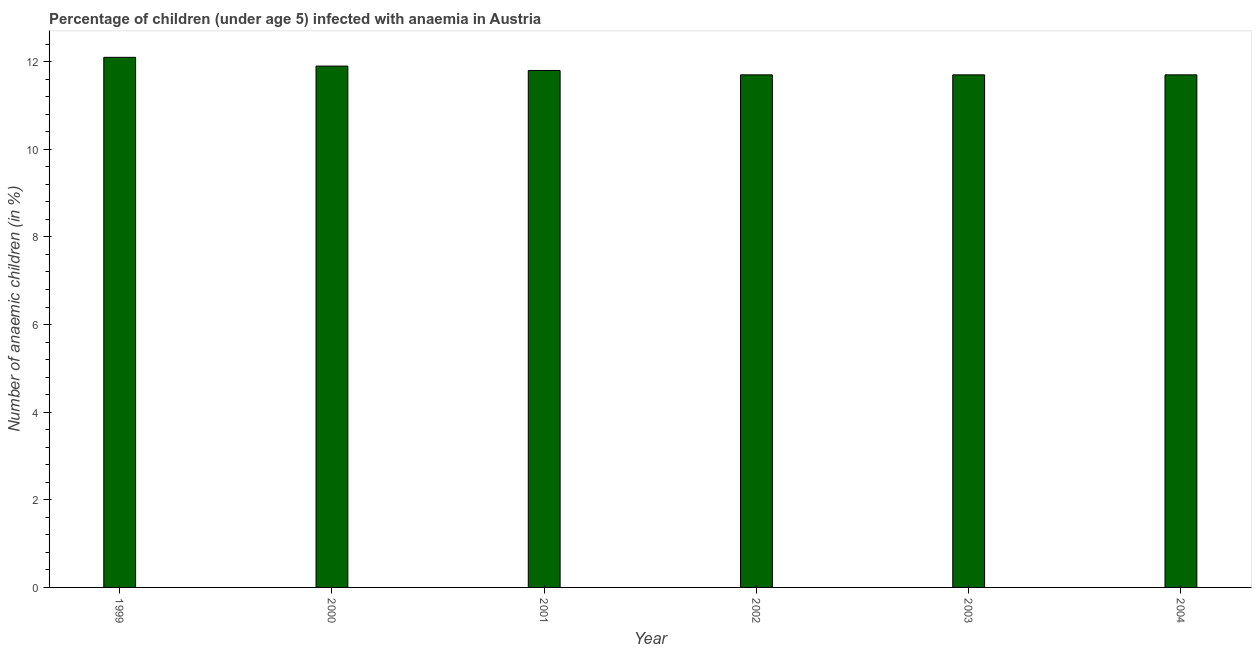What is the title of the graph?
Keep it short and to the point. Percentage of children (under age 5) infected with anaemia in Austria. What is the label or title of the X-axis?
Offer a very short reply. Year. What is the label or title of the Y-axis?
Offer a terse response. Number of anaemic children (in %). What is the number of anaemic children in 2002?
Provide a succinct answer. 11.7. Across all years, what is the maximum number of anaemic children?
Your answer should be compact. 12.1. Across all years, what is the minimum number of anaemic children?
Offer a very short reply. 11.7. In which year was the number of anaemic children minimum?
Your answer should be very brief. 2002. What is the sum of the number of anaemic children?
Provide a short and direct response. 70.9. What is the average number of anaemic children per year?
Provide a succinct answer. 11.82. What is the median number of anaemic children?
Your answer should be very brief. 11.75. In how many years, is the number of anaemic children greater than 6 %?
Your answer should be compact. 6. What is the ratio of the number of anaemic children in 1999 to that in 2004?
Your answer should be very brief. 1.03. Is the number of anaemic children in 2000 less than that in 2002?
Ensure brevity in your answer.  No. Is the sum of the number of anaemic children in 2003 and 2004 greater than the maximum number of anaemic children across all years?
Keep it short and to the point. Yes. What is the difference between the highest and the lowest number of anaemic children?
Offer a terse response. 0.4. How many bars are there?
Offer a terse response. 6. Are all the bars in the graph horizontal?
Make the answer very short. No. How many years are there in the graph?
Your answer should be compact. 6. What is the difference between two consecutive major ticks on the Y-axis?
Your answer should be compact. 2. Are the values on the major ticks of Y-axis written in scientific E-notation?
Ensure brevity in your answer.  No. What is the Number of anaemic children (in %) of 2000?
Offer a terse response. 11.9. What is the difference between the Number of anaemic children (in %) in 1999 and 2000?
Your answer should be very brief. 0.2. What is the difference between the Number of anaemic children (in %) in 1999 and 2002?
Give a very brief answer. 0.4. What is the difference between the Number of anaemic children (in %) in 1999 and 2003?
Make the answer very short. 0.4. What is the difference between the Number of anaemic children (in %) in 1999 and 2004?
Your answer should be very brief. 0.4. What is the difference between the Number of anaemic children (in %) in 2000 and 2001?
Offer a very short reply. 0.1. What is the difference between the Number of anaemic children (in %) in 2000 and 2003?
Make the answer very short. 0.2. What is the difference between the Number of anaemic children (in %) in 2001 and 2002?
Your response must be concise. 0.1. What is the difference between the Number of anaemic children (in %) in 2002 and 2004?
Your answer should be very brief. 0. What is the difference between the Number of anaemic children (in %) in 2003 and 2004?
Offer a very short reply. 0. What is the ratio of the Number of anaemic children (in %) in 1999 to that in 2000?
Your answer should be very brief. 1.02. What is the ratio of the Number of anaemic children (in %) in 1999 to that in 2002?
Give a very brief answer. 1.03. What is the ratio of the Number of anaemic children (in %) in 1999 to that in 2003?
Keep it short and to the point. 1.03. What is the ratio of the Number of anaemic children (in %) in 1999 to that in 2004?
Provide a succinct answer. 1.03. What is the ratio of the Number of anaemic children (in %) in 2000 to that in 2002?
Provide a short and direct response. 1.02. What is the ratio of the Number of anaemic children (in %) in 2000 to that in 2003?
Give a very brief answer. 1.02. What is the ratio of the Number of anaemic children (in %) in 2002 to that in 2004?
Your answer should be compact. 1. 